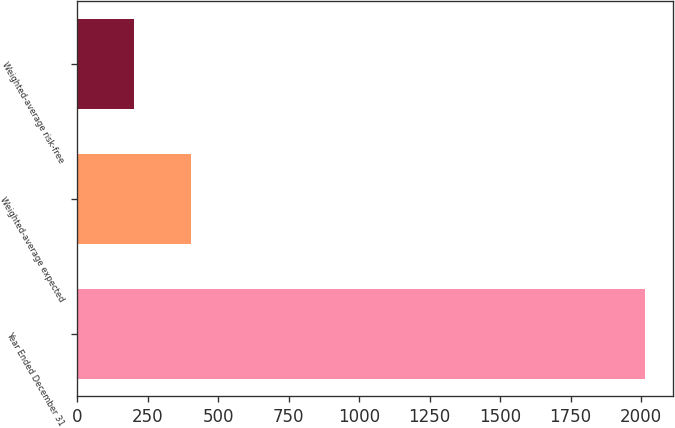Convert chart. <chart><loc_0><loc_0><loc_500><loc_500><bar_chart><fcel>Year Ended December 31<fcel>Weighted-average expected<fcel>Weighted-average risk-free<nl><fcel>2013<fcel>403.51<fcel>202.32<nl></chart> 